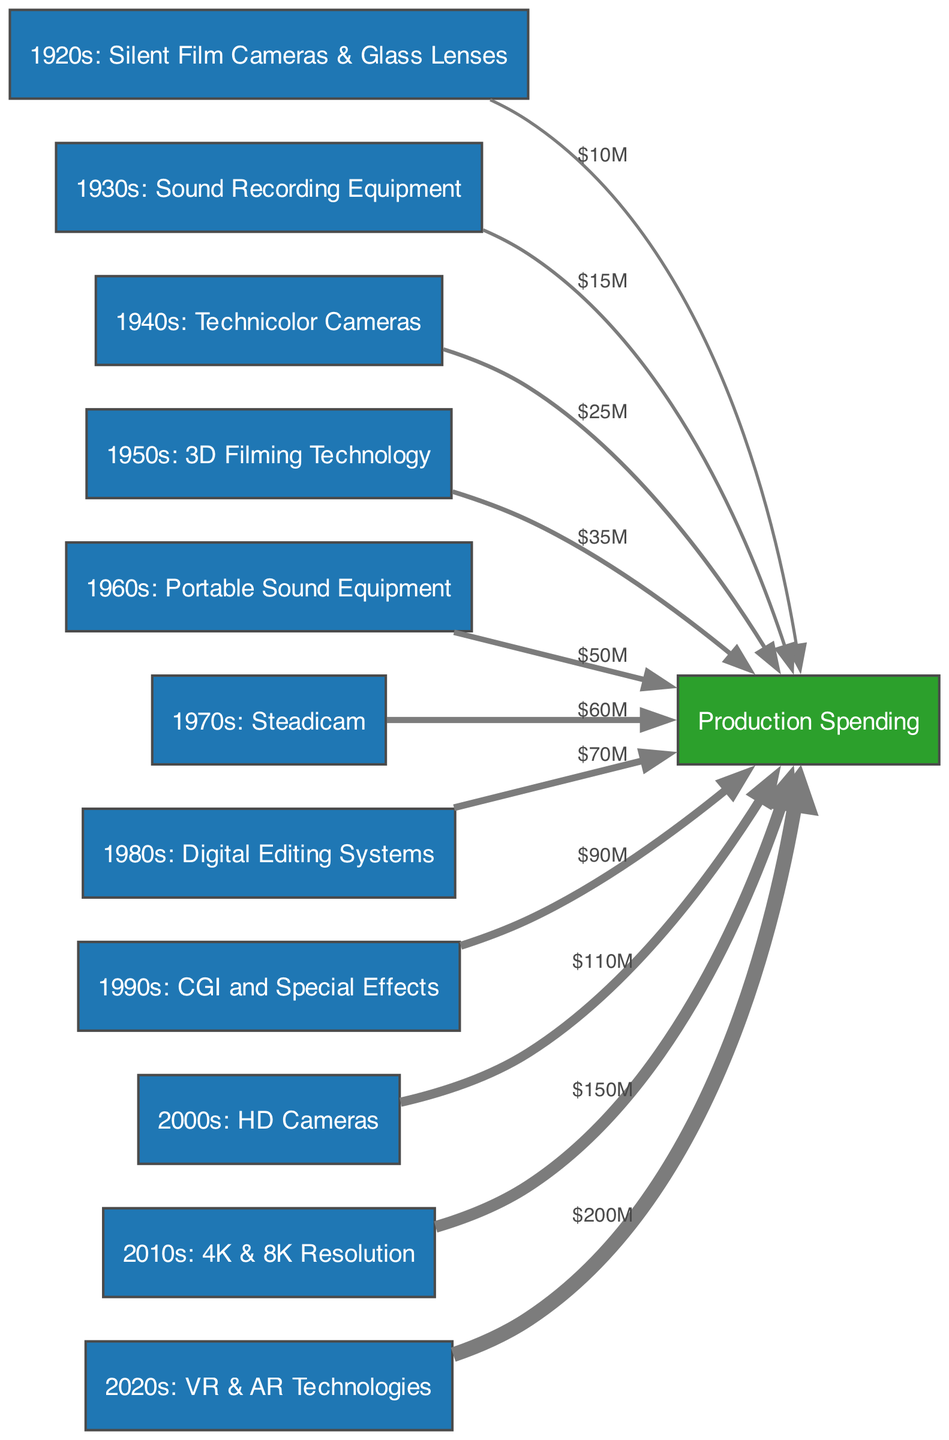what's the total production spending depicted in the diagram? By examining all the links connecting film equipment to production spending, we add up the values shown: 10 + 15 + 25 + 35 + 50 + 60 + 70 + 90 + 110 + 150 + 200, which equals 820 million dollars
Answer: 820 million dollars which decade's film equipment shows the highest spending? Looking at the links from each decade's film equipment to production spending, we see that the 2020s with 200 million dollars has the highest spending compared to all other decades listed
Answer: 2020s how many different decades of film equipment are shown in the diagram? Counting the nodes labeled with decade film equipment, we see there are 11 unique nodes spanning the 1920s to the 2020s
Answer: 11 what is the spending associated with 1980s film equipment? From the link connecting the 1980s Film Equipment to Production Spending, the value shown is 70 million dollars
Answer: 70 million dollars how does production spending change from the 1950s to the 2010s? We first take the value from the 1950s, which is 35 million dollars, and the value from the 2010s, which is 150 million dollars. The difference shows a remarkable rise of 115 million dollars, indicating significant technological advancement and investment in that time frame
Answer: 115 million dollars which decade saw the introduction of VR & AR technologies in film? By navigating through the nodes to find the one that represents VR & AR technologies, we identify it is associated with the 2020s
Answer: 2020s what was the production spending in the 1940s? The link from 1940s Film Equipment to Production Spending indicates that 25 million dollars was allocated during that decade
Answer: 25 million dollars which decade had the first film equipment investment above 50 million dollars? Reviewing the spending values from each decade, we find that the 1960s is the first to reach above 50 million dollars, with a spending amount of 50 million dollars
Answer: 1960s how many edges are connecting to 2000s film equipment? By inspecting the flow from the 2000s Film Equipment node, we see it only connects directly to one edge pointing to Production Spending
Answer: 1 